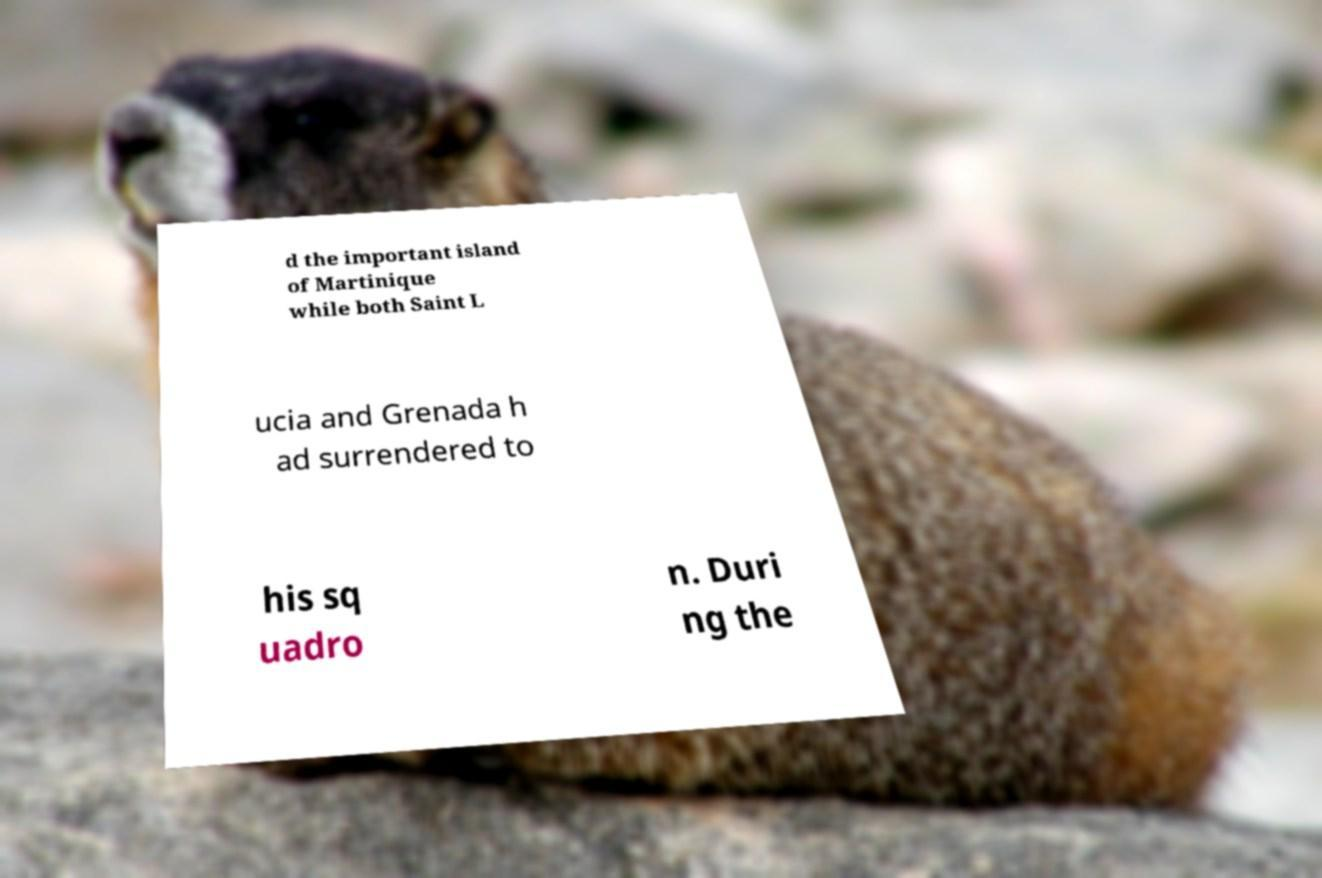Could you assist in decoding the text presented in this image and type it out clearly? d the important island of Martinique while both Saint L ucia and Grenada h ad surrendered to his sq uadro n. Duri ng the 